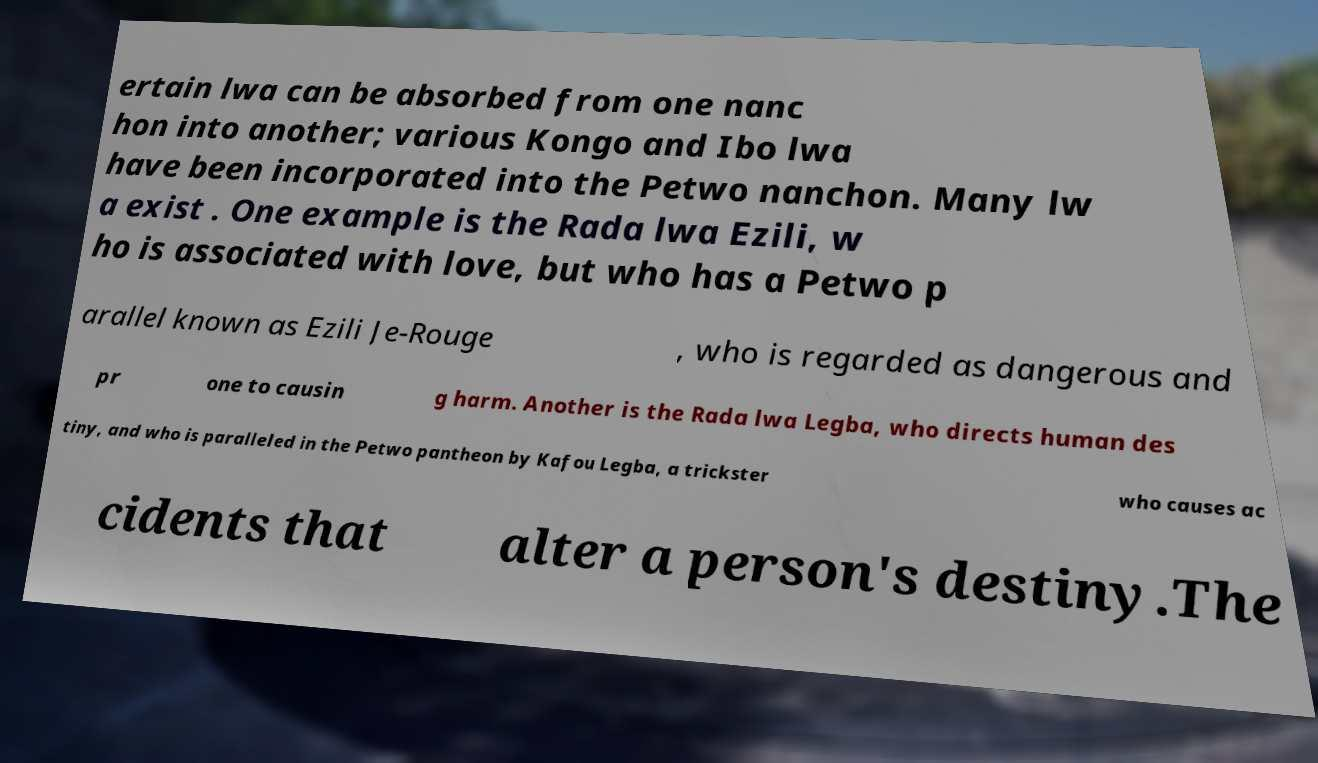I need the written content from this picture converted into text. Can you do that? ertain lwa can be absorbed from one nanc hon into another; various Kongo and Ibo lwa have been incorporated into the Petwo nanchon. Many lw a exist . One example is the Rada lwa Ezili, w ho is associated with love, but who has a Petwo p arallel known as Ezili Je-Rouge , who is regarded as dangerous and pr one to causin g harm. Another is the Rada lwa Legba, who directs human des tiny, and who is paralleled in the Petwo pantheon by Kafou Legba, a trickster who causes ac cidents that alter a person's destiny.The 